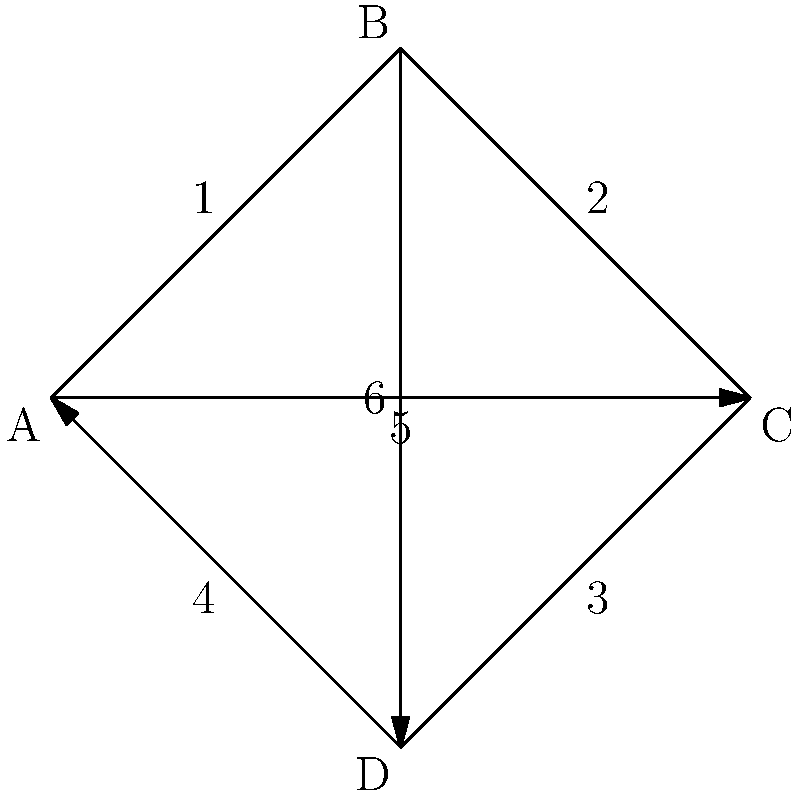Given the network topology shown in the diagram, where A, B, C, and D represent data centers, and the numbered edges represent network connections, what is the minimum number of connections that need to fail for the network to become disconnected (i.e., for at least one data center to become unreachable from the others)? To determine the minimum number of connections that need to fail for the network to become disconnected, we need to analyze the graph's connectivity:

1. The graph represents a network with 4 data centers (nodes) and 6 connections (edges).

2. To disconnect the network, we need to find the minimum cut set - the smallest set of edges whose removal would disconnect the graph.

3. Observe that each node has at least 3 connections:
   - A is connected to B, C, and D
   - B is connected to A, C, and D
   - C is connected to A, B, and D
   - D is connected to A, B, and C

4. This means that removing any two connections will not disconnect the network, as each node will still have at least one connection to the rest of the network.

5. However, if we remove three carefully chosen connections, we can isolate one node from the rest. For example:
   - Removing connections 1, 4, and 5 would isolate node A
   - Removing connections 1, 2, and 6 would isolate node B
   - Removing connections 2, 3, and 5 would isolate node C
   - Removing connections 3, 4, and 6 would isolate node D

6. There is no way to disconnect the network by removing fewer than 3 connections.

Therefore, the minimum number of connections that need to fail for the network to become disconnected is 3.
Answer: 3 connections 